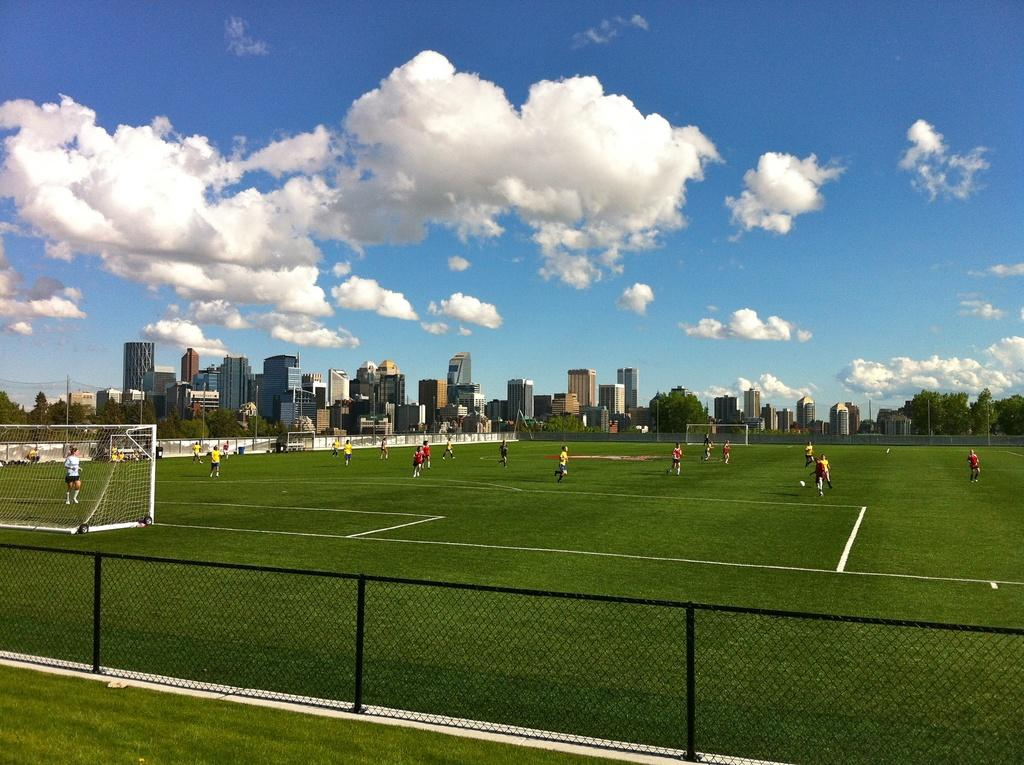How many people are in the image? There are people in the image, but the exact number is not specified. What is the position of the people in the image? The people are on the ground in the image. What type of structures can be seen in the image? There are buildings and houses in the image. What type of natural elements are present in the image? There are trees and clouds visible in the image. How many legs does the rabbit have in the image? There is no rabbit present in the image. What type of property is being sold in the image? There is no information about any property being sold in the image. 